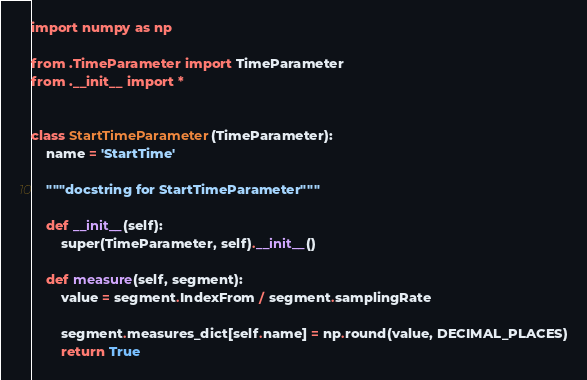Convert code to text. <code><loc_0><loc_0><loc_500><loc_500><_Python_>import numpy as np

from .TimeParameter import TimeParameter
from .__init__ import *


class StartTimeParameter(TimeParameter):
    name = 'StartTime'

    """docstring for StartTimeParameter"""

    def __init__(self):
        super(TimeParameter, self).__init__()

    def measure(self, segment):
        value = segment.IndexFrom / segment.samplingRate

        segment.measures_dict[self.name] = np.round(value, DECIMAL_PLACES)
        return True
</code> 